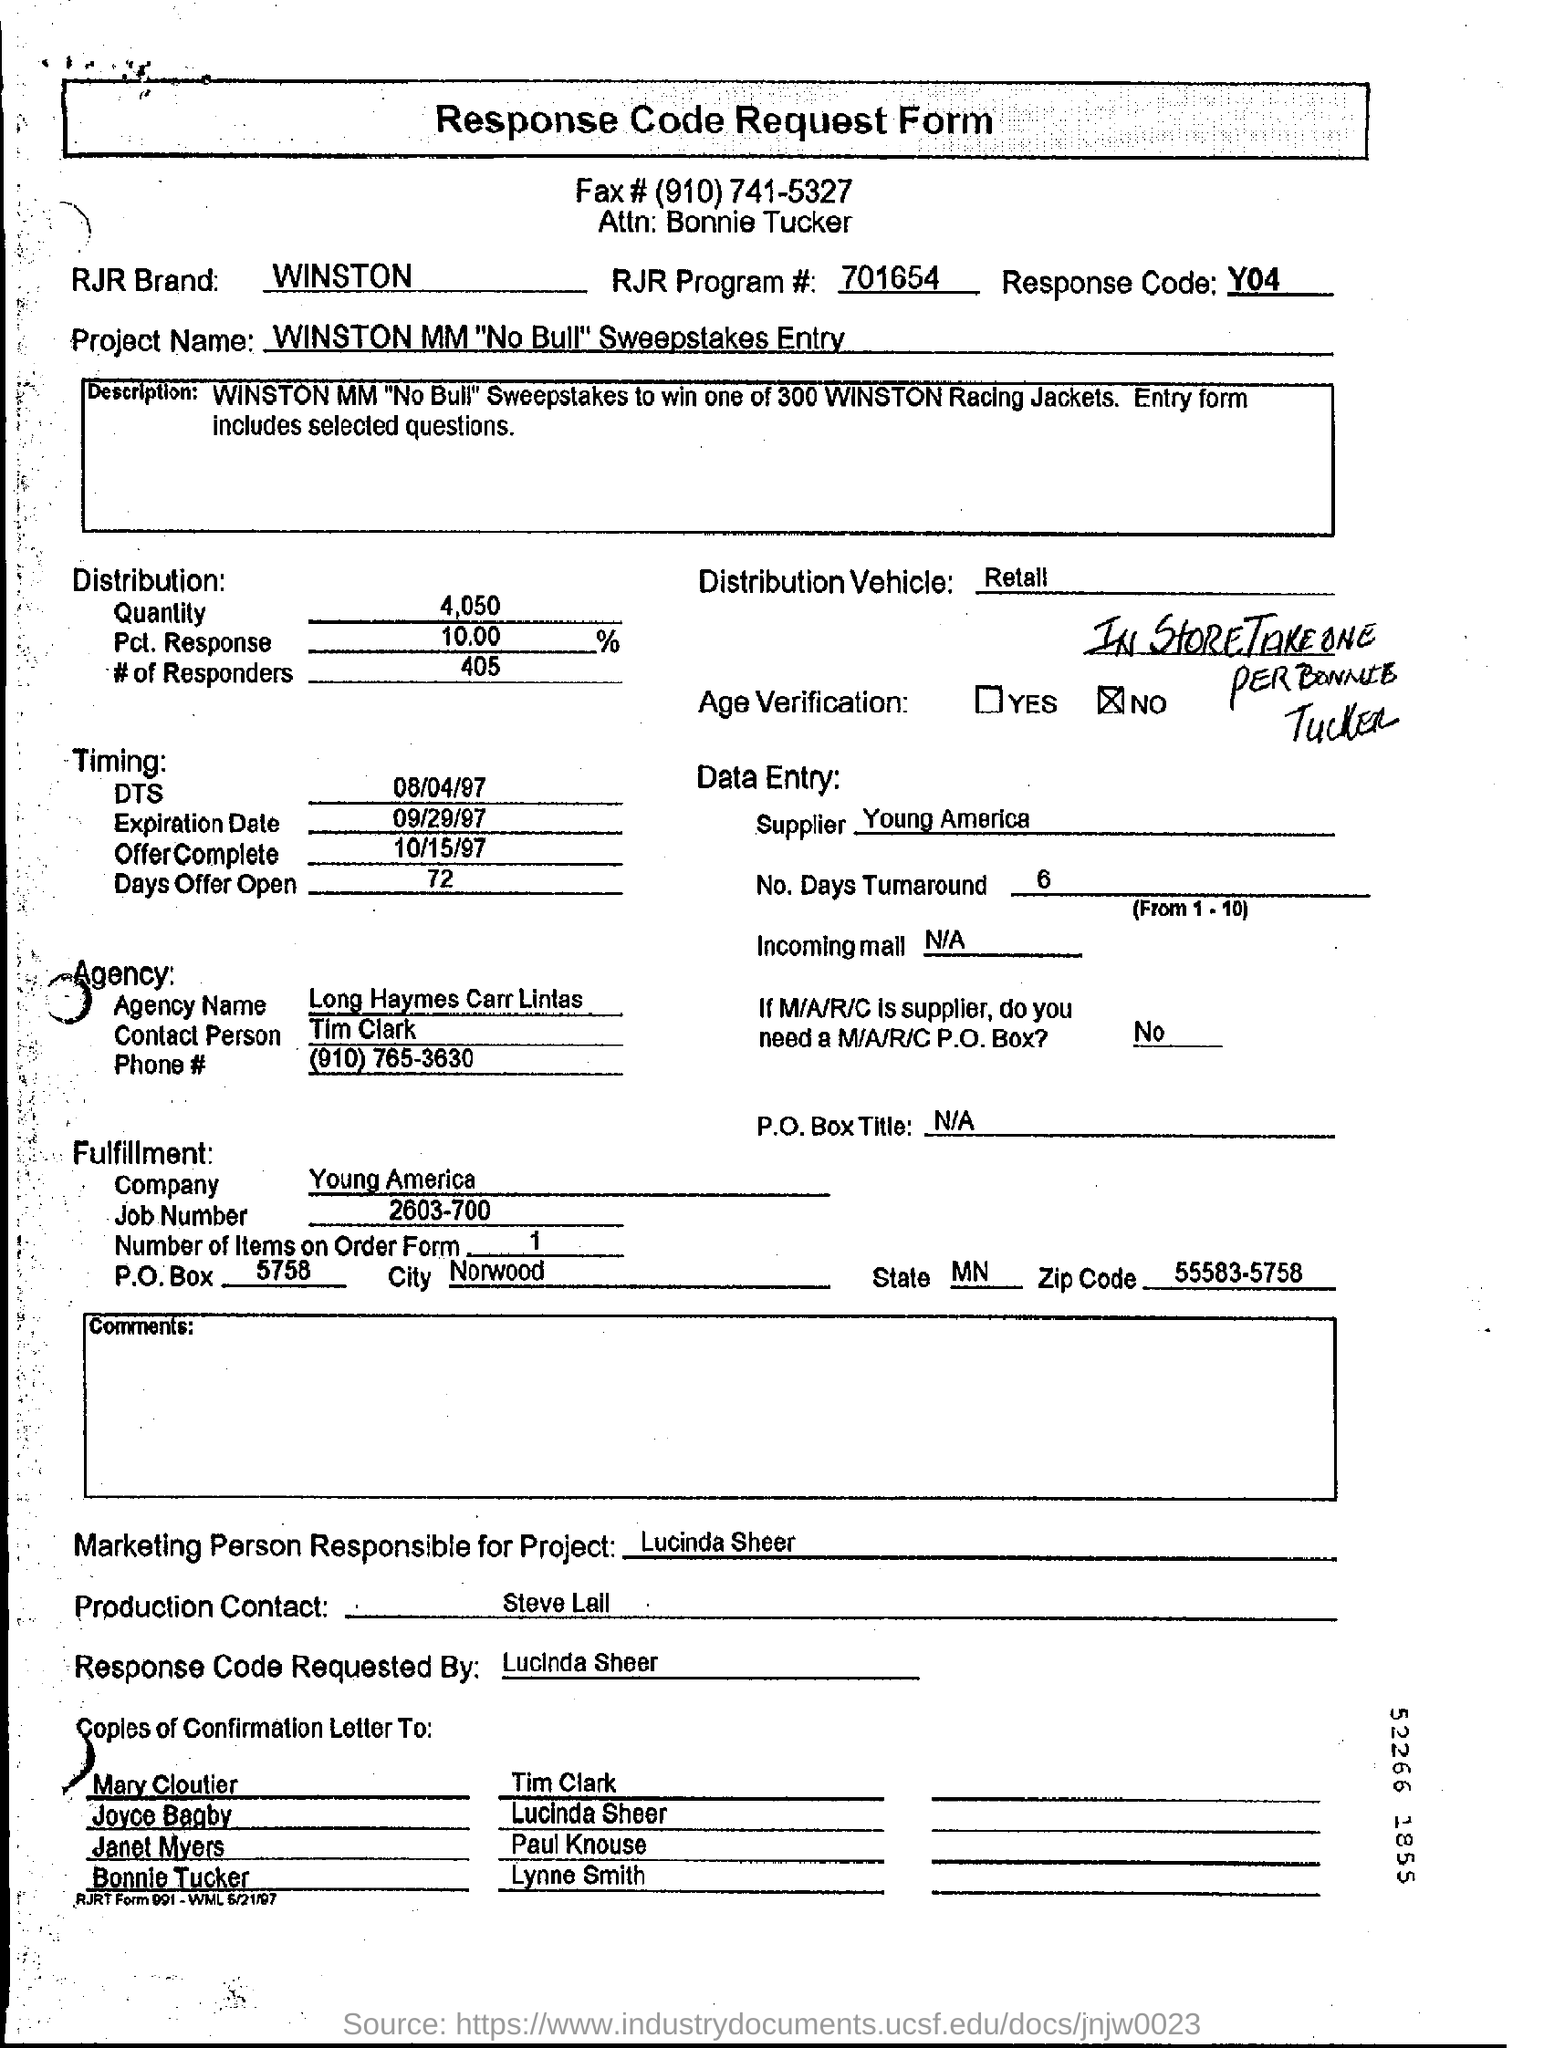List a handful of essential elements in this visual. The response code is Y04.. The marketing person responsible for the project is Lucinda Sheer. The recipient of the attention should be Bonnie Tucker. The person named Steve Lall is the production contact. The Pct. Response is 10.00%. 